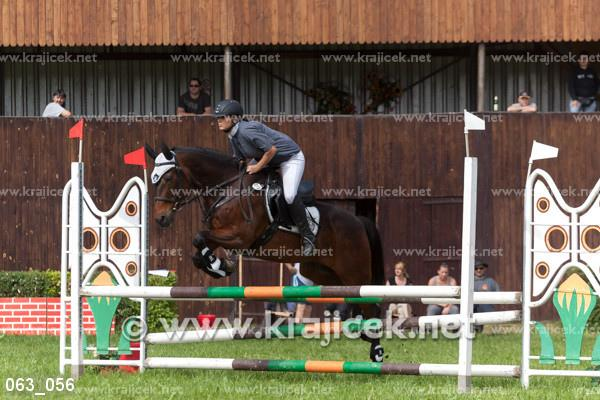Which bar is the horse meant to pass over?

Choices:
A) top bar
B) right vertical
C) left vertical
D) bottom top bar 